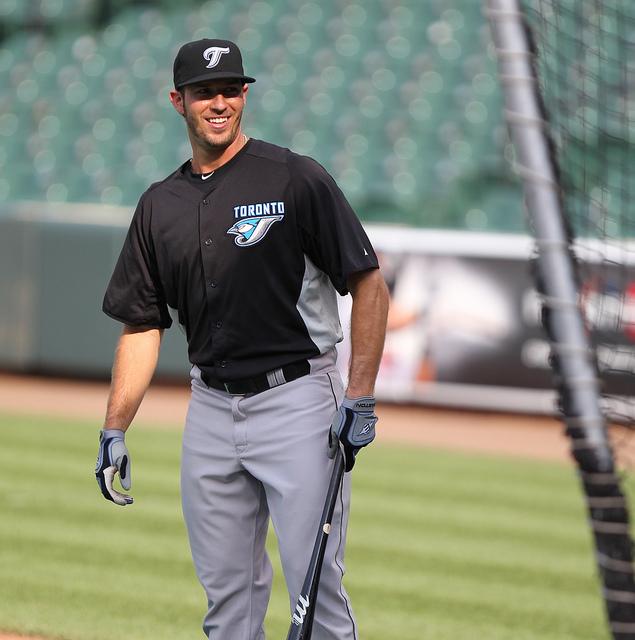What do the gloves help the man with?
Concise answer only. Batting. What is this person doing?
Write a very short answer. Playing baseball. Is he pitching?
Give a very brief answer. No. What is the team's mascot?
Write a very short answer. Blue jay. Which hand is he holding the bat with?
Quick response, please. Left. What team does he play for?
Give a very brief answer. Toronto. Is he reading to swing?
Concise answer only. No. What is the man holding?
Answer briefly. Bat. Which color is the batters uniform?
Quick response, please. Black. Is the man a football player?
Give a very brief answer. No. 